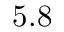<formula> <loc_0><loc_0><loc_500><loc_500>5 . 8</formula> 